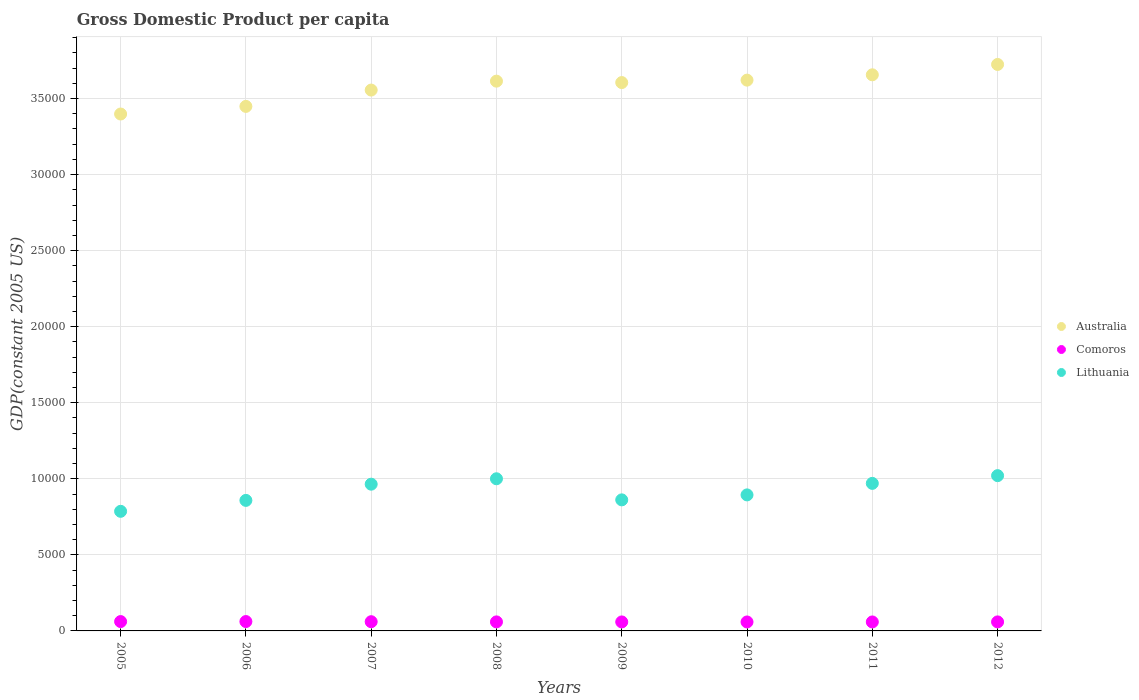What is the GDP per capita in Comoros in 2010?
Your answer should be compact. 589.25. Across all years, what is the maximum GDP per capita in Australia?
Provide a succinct answer. 3.72e+04. Across all years, what is the minimum GDP per capita in Comoros?
Keep it short and to the point. 589.25. In which year was the GDP per capita in Comoros maximum?
Offer a very short reply. 2006. In which year was the GDP per capita in Australia minimum?
Give a very brief answer. 2005. What is the total GDP per capita in Lithuania in the graph?
Your answer should be compact. 7.36e+04. What is the difference between the GDP per capita in Comoros in 2009 and that in 2011?
Your answer should be very brief. 0.83. What is the difference between the GDP per capita in Lithuania in 2006 and the GDP per capita in Australia in 2011?
Provide a succinct answer. -2.80e+04. What is the average GDP per capita in Lithuania per year?
Your response must be concise. 9195.13. In the year 2011, what is the difference between the GDP per capita in Australia and GDP per capita in Lithuania?
Provide a short and direct response. 2.69e+04. In how many years, is the GDP per capita in Comoros greater than 19000 US$?
Keep it short and to the point. 0. What is the ratio of the GDP per capita in Australia in 2005 to that in 2007?
Offer a terse response. 0.96. Is the difference between the GDP per capita in Australia in 2008 and 2009 greater than the difference between the GDP per capita in Lithuania in 2008 and 2009?
Your response must be concise. No. What is the difference between the highest and the second highest GDP per capita in Lithuania?
Give a very brief answer. 205.45. What is the difference between the highest and the lowest GDP per capita in Australia?
Make the answer very short. 3258.44. Is it the case that in every year, the sum of the GDP per capita in Australia and GDP per capita in Comoros  is greater than the GDP per capita in Lithuania?
Offer a terse response. Yes. Does the GDP per capita in Lithuania monotonically increase over the years?
Your answer should be compact. No. Is the GDP per capita in Australia strictly greater than the GDP per capita in Lithuania over the years?
Ensure brevity in your answer.  Yes. Are the values on the major ticks of Y-axis written in scientific E-notation?
Your response must be concise. No. Does the graph contain grids?
Offer a terse response. Yes. What is the title of the graph?
Keep it short and to the point. Gross Domestic Product per capita. What is the label or title of the X-axis?
Your answer should be very brief. Years. What is the label or title of the Y-axis?
Your answer should be compact. GDP(constant 2005 US). What is the GDP(constant 2005 US) of Australia in 2005?
Make the answer very short. 3.40e+04. What is the GDP(constant 2005 US) in Comoros in 2005?
Provide a succinct answer. 614.86. What is the GDP(constant 2005 US) of Lithuania in 2005?
Your response must be concise. 7863.16. What is the GDP(constant 2005 US) of Australia in 2006?
Your answer should be compact. 3.45e+04. What is the GDP(constant 2005 US) of Comoros in 2006?
Ensure brevity in your answer.  616.02. What is the GDP(constant 2005 US) in Lithuania in 2006?
Your response must be concise. 8581.45. What is the GDP(constant 2005 US) in Australia in 2007?
Keep it short and to the point. 3.56e+04. What is the GDP(constant 2005 US) in Comoros in 2007?
Your response must be concise. 606.04. What is the GDP(constant 2005 US) in Lithuania in 2007?
Offer a very short reply. 9646.79. What is the GDP(constant 2005 US) of Australia in 2008?
Provide a succinct answer. 3.61e+04. What is the GDP(constant 2005 US) of Comoros in 2008?
Offer a very short reply. 593.83. What is the GDP(constant 2005 US) of Lithuania in 2008?
Your answer should be very brief. 1.00e+04. What is the GDP(constant 2005 US) in Australia in 2009?
Your answer should be very brief. 3.61e+04. What is the GDP(constant 2005 US) of Comoros in 2009?
Your answer should be compact. 590.82. What is the GDP(constant 2005 US) of Lithuania in 2009?
Provide a succinct answer. 8615.99. What is the GDP(constant 2005 US) of Australia in 2010?
Offer a very short reply. 3.62e+04. What is the GDP(constant 2005 US) of Comoros in 2010?
Ensure brevity in your answer.  589.25. What is the GDP(constant 2005 US) of Lithuania in 2010?
Your answer should be compact. 8942.85. What is the GDP(constant 2005 US) in Australia in 2011?
Provide a succinct answer. 3.66e+04. What is the GDP(constant 2005 US) of Comoros in 2011?
Keep it short and to the point. 589.98. What is the GDP(constant 2005 US) of Lithuania in 2011?
Your response must be concise. 9700.06. What is the GDP(constant 2005 US) of Australia in 2012?
Provide a short and direct response. 3.72e+04. What is the GDP(constant 2005 US) in Comoros in 2012?
Ensure brevity in your answer.  593.03. What is the GDP(constant 2005 US) of Lithuania in 2012?
Your answer should be very brief. 1.02e+04. Across all years, what is the maximum GDP(constant 2005 US) in Australia?
Your answer should be very brief. 3.72e+04. Across all years, what is the maximum GDP(constant 2005 US) in Comoros?
Your response must be concise. 616.02. Across all years, what is the maximum GDP(constant 2005 US) of Lithuania?
Make the answer very short. 1.02e+04. Across all years, what is the minimum GDP(constant 2005 US) in Australia?
Give a very brief answer. 3.40e+04. Across all years, what is the minimum GDP(constant 2005 US) in Comoros?
Your answer should be compact. 589.25. Across all years, what is the minimum GDP(constant 2005 US) in Lithuania?
Your answer should be very brief. 7863.16. What is the total GDP(constant 2005 US) in Australia in the graph?
Ensure brevity in your answer.  2.86e+05. What is the total GDP(constant 2005 US) of Comoros in the graph?
Your response must be concise. 4793.83. What is the total GDP(constant 2005 US) of Lithuania in the graph?
Provide a succinct answer. 7.36e+04. What is the difference between the GDP(constant 2005 US) in Australia in 2005 and that in 2006?
Offer a terse response. -501.18. What is the difference between the GDP(constant 2005 US) in Comoros in 2005 and that in 2006?
Provide a short and direct response. -1.16. What is the difference between the GDP(constant 2005 US) in Lithuania in 2005 and that in 2006?
Give a very brief answer. -718.29. What is the difference between the GDP(constant 2005 US) in Australia in 2005 and that in 2007?
Provide a succinct answer. -1574.16. What is the difference between the GDP(constant 2005 US) in Comoros in 2005 and that in 2007?
Offer a terse response. 8.82. What is the difference between the GDP(constant 2005 US) in Lithuania in 2005 and that in 2007?
Provide a short and direct response. -1783.63. What is the difference between the GDP(constant 2005 US) of Australia in 2005 and that in 2008?
Your response must be concise. -2160.53. What is the difference between the GDP(constant 2005 US) of Comoros in 2005 and that in 2008?
Your response must be concise. 21.03. What is the difference between the GDP(constant 2005 US) of Lithuania in 2005 and that in 2008?
Give a very brief answer. -2139.5. What is the difference between the GDP(constant 2005 US) of Australia in 2005 and that in 2009?
Offer a terse response. -2067.49. What is the difference between the GDP(constant 2005 US) in Comoros in 2005 and that in 2009?
Offer a terse response. 24.04. What is the difference between the GDP(constant 2005 US) in Lithuania in 2005 and that in 2009?
Make the answer very short. -752.83. What is the difference between the GDP(constant 2005 US) in Australia in 2005 and that in 2010?
Your response must be concise. -2227.41. What is the difference between the GDP(constant 2005 US) in Comoros in 2005 and that in 2010?
Provide a succinct answer. 25.61. What is the difference between the GDP(constant 2005 US) in Lithuania in 2005 and that in 2010?
Provide a succinct answer. -1079.69. What is the difference between the GDP(constant 2005 US) of Australia in 2005 and that in 2011?
Provide a succinct answer. -2577.49. What is the difference between the GDP(constant 2005 US) in Comoros in 2005 and that in 2011?
Offer a very short reply. 24.88. What is the difference between the GDP(constant 2005 US) in Lithuania in 2005 and that in 2011?
Provide a short and direct response. -1836.89. What is the difference between the GDP(constant 2005 US) in Australia in 2005 and that in 2012?
Provide a short and direct response. -3258.44. What is the difference between the GDP(constant 2005 US) in Comoros in 2005 and that in 2012?
Offer a terse response. 21.83. What is the difference between the GDP(constant 2005 US) of Lithuania in 2005 and that in 2012?
Your response must be concise. -2344.95. What is the difference between the GDP(constant 2005 US) in Australia in 2006 and that in 2007?
Keep it short and to the point. -1072.98. What is the difference between the GDP(constant 2005 US) in Comoros in 2006 and that in 2007?
Make the answer very short. 9.98. What is the difference between the GDP(constant 2005 US) of Lithuania in 2006 and that in 2007?
Your answer should be very brief. -1065.34. What is the difference between the GDP(constant 2005 US) in Australia in 2006 and that in 2008?
Offer a terse response. -1659.35. What is the difference between the GDP(constant 2005 US) in Comoros in 2006 and that in 2008?
Provide a short and direct response. 22.19. What is the difference between the GDP(constant 2005 US) in Lithuania in 2006 and that in 2008?
Provide a succinct answer. -1421.22. What is the difference between the GDP(constant 2005 US) in Australia in 2006 and that in 2009?
Provide a succinct answer. -1566.32. What is the difference between the GDP(constant 2005 US) of Comoros in 2006 and that in 2009?
Provide a short and direct response. 25.2. What is the difference between the GDP(constant 2005 US) in Lithuania in 2006 and that in 2009?
Provide a short and direct response. -34.54. What is the difference between the GDP(constant 2005 US) in Australia in 2006 and that in 2010?
Keep it short and to the point. -1726.23. What is the difference between the GDP(constant 2005 US) of Comoros in 2006 and that in 2010?
Offer a terse response. 26.77. What is the difference between the GDP(constant 2005 US) in Lithuania in 2006 and that in 2010?
Offer a very short reply. -361.4. What is the difference between the GDP(constant 2005 US) of Australia in 2006 and that in 2011?
Ensure brevity in your answer.  -2076.31. What is the difference between the GDP(constant 2005 US) in Comoros in 2006 and that in 2011?
Your answer should be compact. 26.03. What is the difference between the GDP(constant 2005 US) in Lithuania in 2006 and that in 2011?
Keep it short and to the point. -1118.61. What is the difference between the GDP(constant 2005 US) in Australia in 2006 and that in 2012?
Offer a very short reply. -2757.26. What is the difference between the GDP(constant 2005 US) in Comoros in 2006 and that in 2012?
Offer a very short reply. 22.99. What is the difference between the GDP(constant 2005 US) in Lithuania in 2006 and that in 2012?
Provide a short and direct response. -1626.66. What is the difference between the GDP(constant 2005 US) in Australia in 2007 and that in 2008?
Ensure brevity in your answer.  -586.37. What is the difference between the GDP(constant 2005 US) in Comoros in 2007 and that in 2008?
Make the answer very short. 12.21. What is the difference between the GDP(constant 2005 US) of Lithuania in 2007 and that in 2008?
Provide a short and direct response. -355.87. What is the difference between the GDP(constant 2005 US) in Australia in 2007 and that in 2009?
Offer a terse response. -493.33. What is the difference between the GDP(constant 2005 US) in Comoros in 2007 and that in 2009?
Offer a terse response. 15.22. What is the difference between the GDP(constant 2005 US) in Lithuania in 2007 and that in 2009?
Give a very brief answer. 1030.8. What is the difference between the GDP(constant 2005 US) in Australia in 2007 and that in 2010?
Your response must be concise. -653.25. What is the difference between the GDP(constant 2005 US) of Comoros in 2007 and that in 2010?
Your response must be concise. 16.79. What is the difference between the GDP(constant 2005 US) in Lithuania in 2007 and that in 2010?
Keep it short and to the point. 703.94. What is the difference between the GDP(constant 2005 US) in Australia in 2007 and that in 2011?
Make the answer very short. -1003.33. What is the difference between the GDP(constant 2005 US) of Comoros in 2007 and that in 2011?
Give a very brief answer. 16.06. What is the difference between the GDP(constant 2005 US) in Lithuania in 2007 and that in 2011?
Offer a very short reply. -53.27. What is the difference between the GDP(constant 2005 US) of Australia in 2007 and that in 2012?
Make the answer very short. -1684.28. What is the difference between the GDP(constant 2005 US) in Comoros in 2007 and that in 2012?
Offer a very short reply. 13.01. What is the difference between the GDP(constant 2005 US) of Lithuania in 2007 and that in 2012?
Ensure brevity in your answer.  -561.32. What is the difference between the GDP(constant 2005 US) of Australia in 2008 and that in 2009?
Provide a short and direct response. 93.03. What is the difference between the GDP(constant 2005 US) in Comoros in 2008 and that in 2009?
Your response must be concise. 3.01. What is the difference between the GDP(constant 2005 US) in Lithuania in 2008 and that in 2009?
Your answer should be compact. 1386.67. What is the difference between the GDP(constant 2005 US) of Australia in 2008 and that in 2010?
Give a very brief answer. -66.88. What is the difference between the GDP(constant 2005 US) of Comoros in 2008 and that in 2010?
Make the answer very short. 4.57. What is the difference between the GDP(constant 2005 US) in Lithuania in 2008 and that in 2010?
Offer a very short reply. 1059.81. What is the difference between the GDP(constant 2005 US) in Australia in 2008 and that in 2011?
Offer a terse response. -416.97. What is the difference between the GDP(constant 2005 US) of Comoros in 2008 and that in 2011?
Give a very brief answer. 3.84. What is the difference between the GDP(constant 2005 US) in Lithuania in 2008 and that in 2011?
Provide a succinct answer. 302.61. What is the difference between the GDP(constant 2005 US) of Australia in 2008 and that in 2012?
Keep it short and to the point. -1097.91. What is the difference between the GDP(constant 2005 US) in Comoros in 2008 and that in 2012?
Keep it short and to the point. 0.79. What is the difference between the GDP(constant 2005 US) in Lithuania in 2008 and that in 2012?
Keep it short and to the point. -205.45. What is the difference between the GDP(constant 2005 US) of Australia in 2009 and that in 2010?
Offer a very short reply. -159.91. What is the difference between the GDP(constant 2005 US) of Comoros in 2009 and that in 2010?
Your answer should be compact. 1.56. What is the difference between the GDP(constant 2005 US) of Lithuania in 2009 and that in 2010?
Your answer should be compact. -326.86. What is the difference between the GDP(constant 2005 US) of Australia in 2009 and that in 2011?
Provide a short and direct response. -510. What is the difference between the GDP(constant 2005 US) of Comoros in 2009 and that in 2011?
Your answer should be very brief. 0.83. What is the difference between the GDP(constant 2005 US) of Lithuania in 2009 and that in 2011?
Your answer should be very brief. -1084.07. What is the difference between the GDP(constant 2005 US) in Australia in 2009 and that in 2012?
Your response must be concise. -1190.95. What is the difference between the GDP(constant 2005 US) of Comoros in 2009 and that in 2012?
Provide a short and direct response. -2.22. What is the difference between the GDP(constant 2005 US) in Lithuania in 2009 and that in 2012?
Ensure brevity in your answer.  -1592.12. What is the difference between the GDP(constant 2005 US) in Australia in 2010 and that in 2011?
Provide a succinct answer. -350.08. What is the difference between the GDP(constant 2005 US) in Comoros in 2010 and that in 2011?
Keep it short and to the point. -0.73. What is the difference between the GDP(constant 2005 US) of Lithuania in 2010 and that in 2011?
Make the answer very short. -757.2. What is the difference between the GDP(constant 2005 US) of Australia in 2010 and that in 2012?
Provide a succinct answer. -1031.03. What is the difference between the GDP(constant 2005 US) in Comoros in 2010 and that in 2012?
Your answer should be compact. -3.78. What is the difference between the GDP(constant 2005 US) in Lithuania in 2010 and that in 2012?
Offer a very short reply. -1265.26. What is the difference between the GDP(constant 2005 US) of Australia in 2011 and that in 2012?
Offer a terse response. -680.95. What is the difference between the GDP(constant 2005 US) of Comoros in 2011 and that in 2012?
Ensure brevity in your answer.  -3.05. What is the difference between the GDP(constant 2005 US) in Lithuania in 2011 and that in 2012?
Provide a short and direct response. -508.05. What is the difference between the GDP(constant 2005 US) in Australia in 2005 and the GDP(constant 2005 US) in Comoros in 2006?
Make the answer very short. 3.34e+04. What is the difference between the GDP(constant 2005 US) of Australia in 2005 and the GDP(constant 2005 US) of Lithuania in 2006?
Your answer should be compact. 2.54e+04. What is the difference between the GDP(constant 2005 US) of Comoros in 2005 and the GDP(constant 2005 US) of Lithuania in 2006?
Offer a terse response. -7966.59. What is the difference between the GDP(constant 2005 US) in Australia in 2005 and the GDP(constant 2005 US) in Comoros in 2007?
Ensure brevity in your answer.  3.34e+04. What is the difference between the GDP(constant 2005 US) of Australia in 2005 and the GDP(constant 2005 US) of Lithuania in 2007?
Ensure brevity in your answer.  2.43e+04. What is the difference between the GDP(constant 2005 US) in Comoros in 2005 and the GDP(constant 2005 US) in Lithuania in 2007?
Make the answer very short. -9031.93. What is the difference between the GDP(constant 2005 US) of Australia in 2005 and the GDP(constant 2005 US) of Comoros in 2008?
Provide a short and direct response. 3.34e+04. What is the difference between the GDP(constant 2005 US) in Australia in 2005 and the GDP(constant 2005 US) in Lithuania in 2008?
Provide a succinct answer. 2.40e+04. What is the difference between the GDP(constant 2005 US) in Comoros in 2005 and the GDP(constant 2005 US) in Lithuania in 2008?
Offer a very short reply. -9387.8. What is the difference between the GDP(constant 2005 US) in Australia in 2005 and the GDP(constant 2005 US) in Comoros in 2009?
Your response must be concise. 3.34e+04. What is the difference between the GDP(constant 2005 US) of Australia in 2005 and the GDP(constant 2005 US) of Lithuania in 2009?
Make the answer very short. 2.54e+04. What is the difference between the GDP(constant 2005 US) of Comoros in 2005 and the GDP(constant 2005 US) of Lithuania in 2009?
Your answer should be compact. -8001.13. What is the difference between the GDP(constant 2005 US) in Australia in 2005 and the GDP(constant 2005 US) in Comoros in 2010?
Offer a very short reply. 3.34e+04. What is the difference between the GDP(constant 2005 US) of Australia in 2005 and the GDP(constant 2005 US) of Lithuania in 2010?
Offer a terse response. 2.50e+04. What is the difference between the GDP(constant 2005 US) of Comoros in 2005 and the GDP(constant 2005 US) of Lithuania in 2010?
Give a very brief answer. -8327.99. What is the difference between the GDP(constant 2005 US) of Australia in 2005 and the GDP(constant 2005 US) of Comoros in 2011?
Provide a short and direct response. 3.34e+04. What is the difference between the GDP(constant 2005 US) of Australia in 2005 and the GDP(constant 2005 US) of Lithuania in 2011?
Give a very brief answer. 2.43e+04. What is the difference between the GDP(constant 2005 US) in Comoros in 2005 and the GDP(constant 2005 US) in Lithuania in 2011?
Ensure brevity in your answer.  -9085.19. What is the difference between the GDP(constant 2005 US) in Australia in 2005 and the GDP(constant 2005 US) in Comoros in 2012?
Keep it short and to the point. 3.34e+04. What is the difference between the GDP(constant 2005 US) of Australia in 2005 and the GDP(constant 2005 US) of Lithuania in 2012?
Keep it short and to the point. 2.38e+04. What is the difference between the GDP(constant 2005 US) of Comoros in 2005 and the GDP(constant 2005 US) of Lithuania in 2012?
Ensure brevity in your answer.  -9593.25. What is the difference between the GDP(constant 2005 US) in Australia in 2006 and the GDP(constant 2005 US) in Comoros in 2007?
Give a very brief answer. 3.39e+04. What is the difference between the GDP(constant 2005 US) in Australia in 2006 and the GDP(constant 2005 US) in Lithuania in 2007?
Your answer should be very brief. 2.48e+04. What is the difference between the GDP(constant 2005 US) of Comoros in 2006 and the GDP(constant 2005 US) of Lithuania in 2007?
Your answer should be compact. -9030.77. What is the difference between the GDP(constant 2005 US) in Australia in 2006 and the GDP(constant 2005 US) in Comoros in 2008?
Provide a short and direct response. 3.39e+04. What is the difference between the GDP(constant 2005 US) of Australia in 2006 and the GDP(constant 2005 US) of Lithuania in 2008?
Your answer should be compact. 2.45e+04. What is the difference between the GDP(constant 2005 US) in Comoros in 2006 and the GDP(constant 2005 US) in Lithuania in 2008?
Give a very brief answer. -9386.64. What is the difference between the GDP(constant 2005 US) in Australia in 2006 and the GDP(constant 2005 US) in Comoros in 2009?
Provide a succinct answer. 3.39e+04. What is the difference between the GDP(constant 2005 US) in Australia in 2006 and the GDP(constant 2005 US) in Lithuania in 2009?
Ensure brevity in your answer.  2.59e+04. What is the difference between the GDP(constant 2005 US) of Comoros in 2006 and the GDP(constant 2005 US) of Lithuania in 2009?
Make the answer very short. -7999.97. What is the difference between the GDP(constant 2005 US) in Australia in 2006 and the GDP(constant 2005 US) in Comoros in 2010?
Your response must be concise. 3.39e+04. What is the difference between the GDP(constant 2005 US) in Australia in 2006 and the GDP(constant 2005 US) in Lithuania in 2010?
Your answer should be compact. 2.55e+04. What is the difference between the GDP(constant 2005 US) of Comoros in 2006 and the GDP(constant 2005 US) of Lithuania in 2010?
Provide a succinct answer. -8326.83. What is the difference between the GDP(constant 2005 US) in Australia in 2006 and the GDP(constant 2005 US) in Comoros in 2011?
Your response must be concise. 3.39e+04. What is the difference between the GDP(constant 2005 US) in Australia in 2006 and the GDP(constant 2005 US) in Lithuania in 2011?
Your response must be concise. 2.48e+04. What is the difference between the GDP(constant 2005 US) in Comoros in 2006 and the GDP(constant 2005 US) in Lithuania in 2011?
Keep it short and to the point. -9084.04. What is the difference between the GDP(constant 2005 US) in Australia in 2006 and the GDP(constant 2005 US) in Comoros in 2012?
Your answer should be very brief. 3.39e+04. What is the difference between the GDP(constant 2005 US) in Australia in 2006 and the GDP(constant 2005 US) in Lithuania in 2012?
Offer a very short reply. 2.43e+04. What is the difference between the GDP(constant 2005 US) in Comoros in 2006 and the GDP(constant 2005 US) in Lithuania in 2012?
Provide a short and direct response. -9592.09. What is the difference between the GDP(constant 2005 US) of Australia in 2007 and the GDP(constant 2005 US) of Comoros in 2008?
Your response must be concise. 3.50e+04. What is the difference between the GDP(constant 2005 US) of Australia in 2007 and the GDP(constant 2005 US) of Lithuania in 2008?
Your answer should be very brief. 2.56e+04. What is the difference between the GDP(constant 2005 US) of Comoros in 2007 and the GDP(constant 2005 US) of Lithuania in 2008?
Offer a very short reply. -9396.62. What is the difference between the GDP(constant 2005 US) in Australia in 2007 and the GDP(constant 2005 US) in Comoros in 2009?
Your answer should be very brief. 3.50e+04. What is the difference between the GDP(constant 2005 US) in Australia in 2007 and the GDP(constant 2005 US) in Lithuania in 2009?
Your response must be concise. 2.69e+04. What is the difference between the GDP(constant 2005 US) of Comoros in 2007 and the GDP(constant 2005 US) of Lithuania in 2009?
Provide a short and direct response. -8009.95. What is the difference between the GDP(constant 2005 US) in Australia in 2007 and the GDP(constant 2005 US) in Comoros in 2010?
Your answer should be compact. 3.50e+04. What is the difference between the GDP(constant 2005 US) in Australia in 2007 and the GDP(constant 2005 US) in Lithuania in 2010?
Your answer should be compact. 2.66e+04. What is the difference between the GDP(constant 2005 US) of Comoros in 2007 and the GDP(constant 2005 US) of Lithuania in 2010?
Offer a terse response. -8336.81. What is the difference between the GDP(constant 2005 US) in Australia in 2007 and the GDP(constant 2005 US) in Comoros in 2011?
Keep it short and to the point. 3.50e+04. What is the difference between the GDP(constant 2005 US) in Australia in 2007 and the GDP(constant 2005 US) in Lithuania in 2011?
Ensure brevity in your answer.  2.59e+04. What is the difference between the GDP(constant 2005 US) of Comoros in 2007 and the GDP(constant 2005 US) of Lithuania in 2011?
Offer a terse response. -9094.01. What is the difference between the GDP(constant 2005 US) of Australia in 2007 and the GDP(constant 2005 US) of Comoros in 2012?
Your response must be concise. 3.50e+04. What is the difference between the GDP(constant 2005 US) in Australia in 2007 and the GDP(constant 2005 US) in Lithuania in 2012?
Keep it short and to the point. 2.53e+04. What is the difference between the GDP(constant 2005 US) in Comoros in 2007 and the GDP(constant 2005 US) in Lithuania in 2012?
Ensure brevity in your answer.  -9602.07. What is the difference between the GDP(constant 2005 US) of Australia in 2008 and the GDP(constant 2005 US) of Comoros in 2009?
Your response must be concise. 3.56e+04. What is the difference between the GDP(constant 2005 US) of Australia in 2008 and the GDP(constant 2005 US) of Lithuania in 2009?
Ensure brevity in your answer.  2.75e+04. What is the difference between the GDP(constant 2005 US) in Comoros in 2008 and the GDP(constant 2005 US) in Lithuania in 2009?
Provide a short and direct response. -8022.16. What is the difference between the GDP(constant 2005 US) of Australia in 2008 and the GDP(constant 2005 US) of Comoros in 2010?
Provide a short and direct response. 3.56e+04. What is the difference between the GDP(constant 2005 US) in Australia in 2008 and the GDP(constant 2005 US) in Lithuania in 2010?
Ensure brevity in your answer.  2.72e+04. What is the difference between the GDP(constant 2005 US) of Comoros in 2008 and the GDP(constant 2005 US) of Lithuania in 2010?
Keep it short and to the point. -8349.02. What is the difference between the GDP(constant 2005 US) of Australia in 2008 and the GDP(constant 2005 US) of Comoros in 2011?
Offer a terse response. 3.56e+04. What is the difference between the GDP(constant 2005 US) of Australia in 2008 and the GDP(constant 2005 US) of Lithuania in 2011?
Offer a very short reply. 2.64e+04. What is the difference between the GDP(constant 2005 US) of Comoros in 2008 and the GDP(constant 2005 US) of Lithuania in 2011?
Provide a short and direct response. -9106.23. What is the difference between the GDP(constant 2005 US) of Australia in 2008 and the GDP(constant 2005 US) of Comoros in 2012?
Make the answer very short. 3.56e+04. What is the difference between the GDP(constant 2005 US) of Australia in 2008 and the GDP(constant 2005 US) of Lithuania in 2012?
Offer a terse response. 2.59e+04. What is the difference between the GDP(constant 2005 US) of Comoros in 2008 and the GDP(constant 2005 US) of Lithuania in 2012?
Your response must be concise. -9614.28. What is the difference between the GDP(constant 2005 US) of Australia in 2009 and the GDP(constant 2005 US) of Comoros in 2010?
Provide a short and direct response. 3.55e+04. What is the difference between the GDP(constant 2005 US) of Australia in 2009 and the GDP(constant 2005 US) of Lithuania in 2010?
Offer a very short reply. 2.71e+04. What is the difference between the GDP(constant 2005 US) of Comoros in 2009 and the GDP(constant 2005 US) of Lithuania in 2010?
Provide a succinct answer. -8352.03. What is the difference between the GDP(constant 2005 US) of Australia in 2009 and the GDP(constant 2005 US) of Comoros in 2011?
Ensure brevity in your answer.  3.55e+04. What is the difference between the GDP(constant 2005 US) in Australia in 2009 and the GDP(constant 2005 US) in Lithuania in 2011?
Ensure brevity in your answer.  2.64e+04. What is the difference between the GDP(constant 2005 US) in Comoros in 2009 and the GDP(constant 2005 US) in Lithuania in 2011?
Give a very brief answer. -9109.24. What is the difference between the GDP(constant 2005 US) of Australia in 2009 and the GDP(constant 2005 US) of Comoros in 2012?
Offer a terse response. 3.55e+04. What is the difference between the GDP(constant 2005 US) of Australia in 2009 and the GDP(constant 2005 US) of Lithuania in 2012?
Keep it short and to the point. 2.58e+04. What is the difference between the GDP(constant 2005 US) in Comoros in 2009 and the GDP(constant 2005 US) in Lithuania in 2012?
Make the answer very short. -9617.29. What is the difference between the GDP(constant 2005 US) of Australia in 2010 and the GDP(constant 2005 US) of Comoros in 2011?
Provide a succinct answer. 3.56e+04. What is the difference between the GDP(constant 2005 US) in Australia in 2010 and the GDP(constant 2005 US) in Lithuania in 2011?
Provide a succinct answer. 2.65e+04. What is the difference between the GDP(constant 2005 US) of Comoros in 2010 and the GDP(constant 2005 US) of Lithuania in 2011?
Make the answer very short. -9110.8. What is the difference between the GDP(constant 2005 US) of Australia in 2010 and the GDP(constant 2005 US) of Comoros in 2012?
Keep it short and to the point. 3.56e+04. What is the difference between the GDP(constant 2005 US) in Australia in 2010 and the GDP(constant 2005 US) in Lithuania in 2012?
Provide a short and direct response. 2.60e+04. What is the difference between the GDP(constant 2005 US) in Comoros in 2010 and the GDP(constant 2005 US) in Lithuania in 2012?
Provide a short and direct response. -9618.86. What is the difference between the GDP(constant 2005 US) of Australia in 2011 and the GDP(constant 2005 US) of Comoros in 2012?
Keep it short and to the point. 3.60e+04. What is the difference between the GDP(constant 2005 US) in Australia in 2011 and the GDP(constant 2005 US) in Lithuania in 2012?
Your answer should be very brief. 2.64e+04. What is the difference between the GDP(constant 2005 US) of Comoros in 2011 and the GDP(constant 2005 US) of Lithuania in 2012?
Your response must be concise. -9618.12. What is the average GDP(constant 2005 US) in Australia per year?
Your answer should be very brief. 3.58e+04. What is the average GDP(constant 2005 US) in Comoros per year?
Give a very brief answer. 599.23. What is the average GDP(constant 2005 US) in Lithuania per year?
Offer a very short reply. 9195.13. In the year 2005, what is the difference between the GDP(constant 2005 US) of Australia and GDP(constant 2005 US) of Comoros?
Provide a short and direct response. 3.34e+04. In the year 2005, what is the difference between the GDP(constant 2005 US) of Australia and GDP(constant 2005 US) of Lithuania?
Keep it short and to the point. 2.61e+04. In the year 2005, what is the difference between the GDP(constant 2005 US) of Comoros and GDP(constant 2005 US) of Lithuania?
Give a very brief answer. -7248.3. In the year 2006, what is the difference between the GDP(constant 2005 US) of Australia and GDP(constant 2005 US) of Comoros?
Keep it short and to the point. 3.39e+04. In the year 2006, what is the difference between the GDP(constant 2005 US) in Australia and GDP(constant 2005 US) in Lithuania?
Make the answer very short. 2.59e+04. In the year 2006, what is the difference between the GDP(constant 2005 US) of Comoros and GDP(constant 2005 US) of Lithuania?
Offer a very short reply. -7965.43. In the year 2007, what is the difference between the GDP(constant 2005 US) of Australia and GDP(constant 2005 US) of Comoros?
Offer a very short reply. 3.50e+04. In the year 2007, what is the difference between the GDP(constant 2005 US) of Australia and GDP(constant 2005 US) of Lithuania?
Your response must be concise. 2.59e+04. In the year 2007, what is the difference between the GDP(constant 2005 US) of Comoros and GDP(constant 2005 US) of Lithuania?
Offer a very short reply. -9040.75. In the year 2008, what is the difference between the GDP(constant 2005 US) in Australia and GDP(constant 2005 US) in Comoros?
Your response must be concise. 3.55e+04. In the year 2008, what is the difference between the GDP(constant 2005 US) of Australia and GDP(constant 2005 US) of Lithuania?
Make the answer very short. 2.61e+04. In the year 2008, what is the difference between the GDP(constant 2005 US) in Comoros and GDP(constant 2005 US) in Lithuania?
Provide a short and direct response. -9408.84. In the year 2009, what is the difference between the GDP(constant 2005 US) in Australia and GDP(constant 2005 US) in Comoros?
Ensure brevity in your answer.  3.55e+04. In the year 2009, what is the difference between the GDP(constant 2005 US) in Australia and GDP(constant 2005 US) in Lithuania?
Your answer should be compact. 2.74e+04. In the year 2009, what is the difference between the GDP(constant 2005 US) in Comoros and GDP(constant 2005 US) in Lithuania?
Keep it short and to the point. -8025.17. In the year 2010, what is the difference between the GDP(constant 2005 US) in Australia and GDP(constant 2005 US) in Comoros?
Provide a succinct answer. 3.56e+04. In the year 2010, what is the difference between the GDP(constant 2005 US) of Australia and GDP(constant 2005 US) of Lithuania?
Your answer should be very brief. 2.73e+04. In the year 2010, what is the difference between the GDP(constant 2005 US) in Comoros and GDP(constant 2005 US) in Lithuania?
Make the answer very short. -8353.6. In the year 2011, what is the difference between the GDP(constant 2005 US) in Australia and GDP(constant 2005 US) in Comoros?
Offer a terse response. 3.60e+04. In the year 2011, what is the difference between the GDP(constant 2005 US) of Australia and GDP(constant 2005 US) of Lithuania?
Offer a terse response. 2.69e+04. In the year 2011, what is the difference between the GDP(constant 2005 US) of Comoros and GDP(constant 2005 US) of Lithuania?
Provide a succinct answer. -9110.07. In the year 2012, what is the difference between the GDP(constant 2005 US) in Australia and GDP(constant 2005 US) in Comoros?
Offer a very short reply. 3.66e+04. In the year 2012, what is the difference between the GDP(constant 2005 US) of Australia and GDP(constant 2005 US) of Lithuania?
Provide a short and direct response. 2.70e+04. In the year 2012, what is the difference between the GDP(constant 2005 US) in Comoros and GDP(constant 2005 US) in Lithuania?
Your answer should be compact. -9615.08. What is the ratio of the GDP(constant 2005 US) in Australia in 2005 to that in 2006?
Keep it short and to the point. 0.99. What is the ratio of the GDP(constant 2005 US) in Comoros in 2005 to that in 2006?
Ensure brevity in your answer.  1. What is the ratio of the GDP(constant 2005 US) in Lithuania in 2005 to that in 2006?
Offer a very short reply. 0.92. What is the ratio of the GDP(constant 2005 US) in Australia in 2005 to that in 2007?
Your answer should be very brief. 0.96. What is the ratio of the GDP(constant 2005 US) in Comoros in 2005 to that in 2007?
Make the answer very short. 1.01. What is the ratio of the GDP(constant 2005 US) in Lithuania in 2005 to that in 2007?
Make the answer very short. 0.82. What is the ratio of the GDP(constant 2005 US) in Australia in 2005 to that in 2008?
Provide a short and direct response. 0.94. What is the ratio of the GDP(constant 2005 US) of Comoros in 2005 to that in 2008?
Provide a succinct answer. 1.04. What is the ratio of the GDP(constant 2005 US) of Lithuania in 2005 to that in 2008?
Make the answer very short. 0.79. What is the ratio of the GDP(constant 2005 US) in Australia in 2005 to that in 2009?
Your answer should be compact. 0.94. What is the ratio of the GDP(constant 2005 US) of Comoros in 2005 to that in 2009?
Provide a short and direct response. 1.04. What is the ratio of the GDP(constant 2005 US) of Lithuania in 2005 to that in 2009?
Keep it short and to the point. 0.91. What is the ratio of the GDP(constant 2005 US) in Australia in 2005 to that in 2010?
Your answer should be compact. 0.94. What is the ratio of the GDP(constant 2005 US) of Comoros in 2005 to that in 2010?
Keep it short and to the point. 1.04. What is the ratio of the GDP(constant 2005 US) in Lithuania in 2005 to that in 2010?
Keep it short and to the point. 0.88. What is the ratio of the GDP(constant 2005 US) of Australia in 2005 to that in 2011?
Make the answer very short. 0.93. What is the ratio of the GDP(constant 2005 US) in Comoros in 2005 to that in 2011?
Make the answer very short. 1.04. What is the ratio of the GDP(constant 2005 US) of Lithuania in 2005 to that in 2011?
Ensure brevity in your answer.  0.81. What is the ratio of the GDP(constant 2005 US) of Australia in 2005 to that in 2012?
Provide a succinct answer. 0.91. What is the ratio of the GDP(constant 2005 US) in Comoros in 2005 to that in 2012?
Offer a terse response. 1.04. What is the ratio of the GDP(constant 2005 US) in Lithuania in 2005 to that in 2012?
Give a very brief answer. 0.77. What is the ratio of the GDP(constant 2005 US) in Australia in 2006 to that in 2007?
Keep it short and to the point. 0.97. What is the ratio of the GDP(constant 2005 US) in Comoros in 2006 to that in 2007?
Provide a short and direct response. 1.02. What is the ratio of the GDP(constant 2005 US) in Lithuania in 2006 to that in 2007?
Ensure brevity in your answer.  0.89. What is the ratio of the GDP(constant 2005 US) in Australia in 2006 to that in 2008?
Provide a succinct answer. 0.95. What is the ratio of the GDP(constant 2005 US) in Comoros in 2006 to that in 2008?
Keep it short and to the point. 1.04. What is the ratio of the GDP(constant 2005 US) in Lithuania in 2006 to that in 2008?
Keep it short and to the point. 0.86. What is the ratio of the GDP(constant 2005 US) in Australia in 2006 to that in 2009?
Give a very brief answer. 0.96. What is the ratio of the GDP(constant 2005 US) of Comoros in 2006 to that in 2009?
Ensure brevity in your answer.  1.04. What is the ratio of the GDP(constant 2005 US) of Lithuania in 2006 to that in 2009?
Your answer should be very brief. 1. What is the ratio of the GDP(constant 2005 US) in Australia in 2006 to that in 2010?
Your response must be concise. 0.95. What is the ratio of the GDP(constant 2005 US) in Comoros in 2006 to that in 2010?
Provide a succinct answer. 1.05. What is the ratio of the GDP(constant 2005 US) of Lithuania in 2006 to that in 2010?
Offer a terse response. 0.96. What is the ratio of the GDP(constant 2005 US) of Australia in 2006 to that in 2011?
Offer a very short reply. 0.94. What is the ratio of the GDP(constant 2005 US) in Comoros in 2006 to that in 2011?
Your response must be concise. 1.04. What is the ratio of the GDP(constant 2005 US) of Lithuania in 2006 to that in 2011?
Give a very brief answer. 0.88. What is the ratio of the GDP(constant 2005 US) of Australia in 2006 to that in 2012?
Your response must be concise. 0.93. What is the ratio of the GDP(constant 2005 US) of Comoros in 2006 to that in 2012?
Your answer should be compact. 1.04. What is the ratio of the GDP(constant 2005 US) in Lithuania in 2006 to that in 2012?
Give a very brief answer. 0.84. What is the ratio of the GDP(constant 2005 US) of Australia in 2007 to that in 2008?
Offer a terse response. 0.98. What is the ratio of the GDP(constant 2005 US) of Comoros in 2007 to that in 2008?
Make the answer very short. 1.02. What is the ratio of the GDP(constant 2005 US) of Lithuania in 2007 to that in 2008?
Offer a terse response. 0.96. What is the ratio of the GDP(constant 2005 US) in Australia in 2007 to that in 2009?
Provide a short and direct response. 0.99. What is the ratio of the GDP(constant 2005 US) in Comoros in 2007 to that in 2009?
Make the answer very short. 1.03. What is the ratio of the GDP(constant 2005 US) of Lithuania in 2007 to that in 2009?
Make the answer very short. 1.12. What is the ratio of the GDP(constant 2005 US) in Australia in 2007 to that in 2010?
Make the answer very short. 0.98. What is the ratio of the GDP(constant 2005 US) in Comoros in 2007 to that in 2010?
Offer a terse response. 1.03. What is the ratio of the GDP(constant 2005 US) of Lithuania in 2007 to that in 2010?
Offer a very short reply. 1.08. What is the ratio of the GDP(constant 2005 US) in Australia in 2007 to that in 2011?
Provide a succinct answer. 0.97. What is the ratio of the GDP(constant 2005 US) of Comoros in 2007 to that in 2011?
Keep it short and to the point. 1.03. What is the ratio of the GDP(constant 2005 US) of Lithuania in 2007 to that in 2011?
Offer a terse response. 0.99. What is the ratio of the GDP(constant 2005 US) of Australia in 2007 to that in 2012?
Your response must be concise. 0.95. What is the ratio of the GDP(constant 2005 US) in Comoros in 2007 to that in 2012?
Your response must be concise. 1.02. What is the ratio of the GDP(constant 2005 US) in Lithuania in 2007 to that in 2012?
Your answer should be very brief. 0.94. What is the ratio of the GDP(constant 2005 US) of Australia in 2008 to that in 2009?
Keep it short and to the point. 1. What is the ratio of the GDP(constant 2005 US) in Comoros in 2008 to that in 2009?
Give a very brief answer. 1.01. What is the ratio of the GDP(constant 2005 US) of Lithuania in 2008 to that in 2009?
Your response must be concise. 1.16. What is the ratio of the GDP(constant 2005 US) in Lithuania in 2008 to that in 2010?
Offer a very short reply. 1.12. What is the ratio of the GDP(constant 2005 US) of Australia in 2008 to that in 2011?
Your response must be concise. 0.99. What is the ratio of the GDP(constant 2005 US) in Lithuania in 2008 to that in 2011?
Provide a short and direct response. 1.03. What is the ratio of the GDP(constant 2005 US) of Australia in 2008 to that in 2012?
Make the answer very short. 0.97. What is the ratio of the GDP(constant 2005 US) of Lithuania in 2008 to that in 2012?
Your answer should be very brief. 0.98. What is the ratio of the GDP(constant 2005 US) in Australia in 2009 to that in 2010?
Provide a short and direct response. 1. What is the ratio of the GDP(constant 2005 US) of Comoros in 2009 to that in 2010?
Your response must be concise. 1. What is the ratio of the GDP(constant 2005 US) in Lithuania in 2009 to that in 2010?
Offer a very short reply. 0.96. What is the ratio of the GDP(constant 2005 US) of Australia in 2009 to that in 2011?
Offer a terse response. 0.99. What is the ratio of the GDP(constant 2005 US) in Lithuania in 2009 to that in 2011?
Provide a short and direct response. 0.89. What is the ratio of the GDP(constant 2005 US) of Australia in 2009 to that in 2012?
Give a very brief answer. 0.97. What is the ratio of the GDP(constant 2005 US) in Comoros in 2009 to that in 2012?
Your answer should be very brief. 1. What is the ratio of the GDP(constant 2005 US) of Lithuania in 2009 to that in 2012?
Offer a terse response. 0.84. What is the ratio of the GDP(constant 2005 US) in Australia in 2010 to that in 2011?
Make the answer very short. 0.99. What is the ratio of the GDP(constant 2005 US) in Comoros in 2010 to that in 2011?
Your answer should be very brief. 1. What is the ratio of the GDP(constant 2005 US) of Lithuania in 2010 to that in 2011?
Ensure brevity in your answer.  0.92. What is the ratio of the GDP(constant 2005 US) of Australia in 2010 to that in 2012?
Your response must be concise. 0.97. What is the ratio of the GDP(constant 2005 US) of Comoros in 2010 to that in 2012?
Keep it short and to the point. 0.99. What is the ratio of the GDP(constant 2005 US) in Lithuania in 2010 to that in 2012?
Provide a succinct answer. 0.88. What is the ratio of the GDP(constant 2005 US) in Australia in 2011 to that in 2012?
Offer a terse response. 0.98. What is the ratio of the GDP(constant 2005 US) in Comoros in 2011 to that in 2012?
Provide a succinct answer. 0.99. What is the ratio of the GDP(constant 2005 US) in Lithuania in 2011 to that in 2012?
Provide a succinct answer. 0.95. What is the difference between the highest and the second highest GDP(constant 2005 US) of Australia?
Provide a succinct answer. 680.95. What is the difference between the highest and the second highest GDP(constant 2005 US) in Comoros?
Keep it short and to the point. 1.16. What is the difference between the highest and the second highest GDP(constant 2005 US) of Lithuania?
Offer a terse response. 205.45. What is the difference between the highest and the lowest GDP(constant 2005 US) of Australia?
Provide a succinct answer. 3258.44. What is the difference between the highest and the lowest GDP(constant 2005 US) of Comoros?
Make the answer very short. 26.77. What is the difference between the highest and the lowest GDP(constant 2005 US) in Lithuania?
Make the answer very short. 2344.95. 